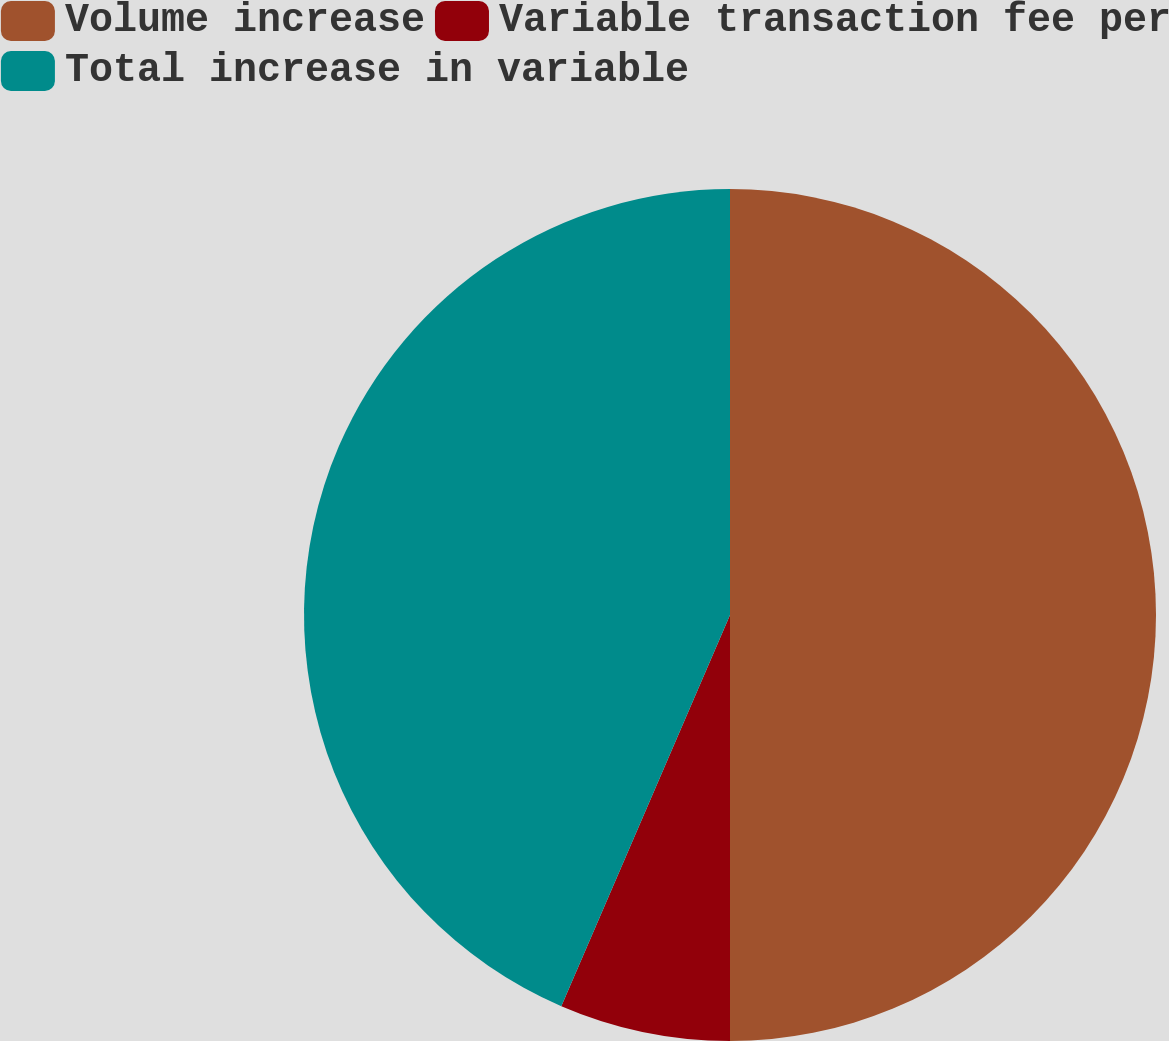Convert chart. <chart><loc_0><loc_0><loc_500><loc_500><pie_chart><fcel>Volume increase<fcel>Variable transaction fee per<fcel>Total increase in variable<nl><fcel>50.0%<fcel>6.48%<fcel>43.52%<nl></chart> 